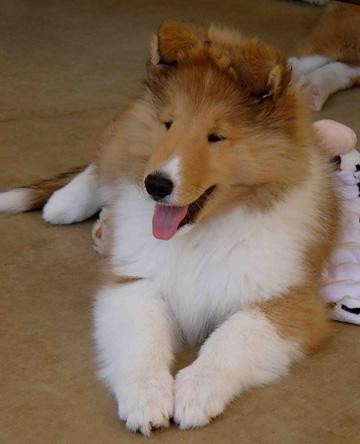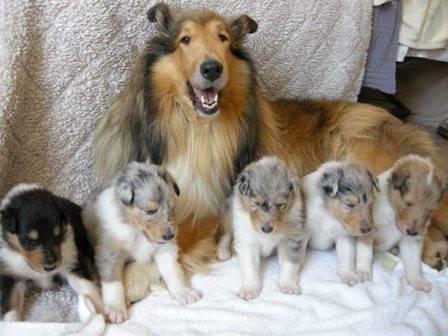The first image is the image on the left, the second image is the image on the right. Examine the images to the left and right. Is the description "There are at most 4 collies in the pair of images." accurate? Answer yes or no. No. The first image is the image on the left, the second image is the image on the right. Given the left and right images, does the statement "The right image contains exactly three dogs." hold true? Answer yes or no. No. 